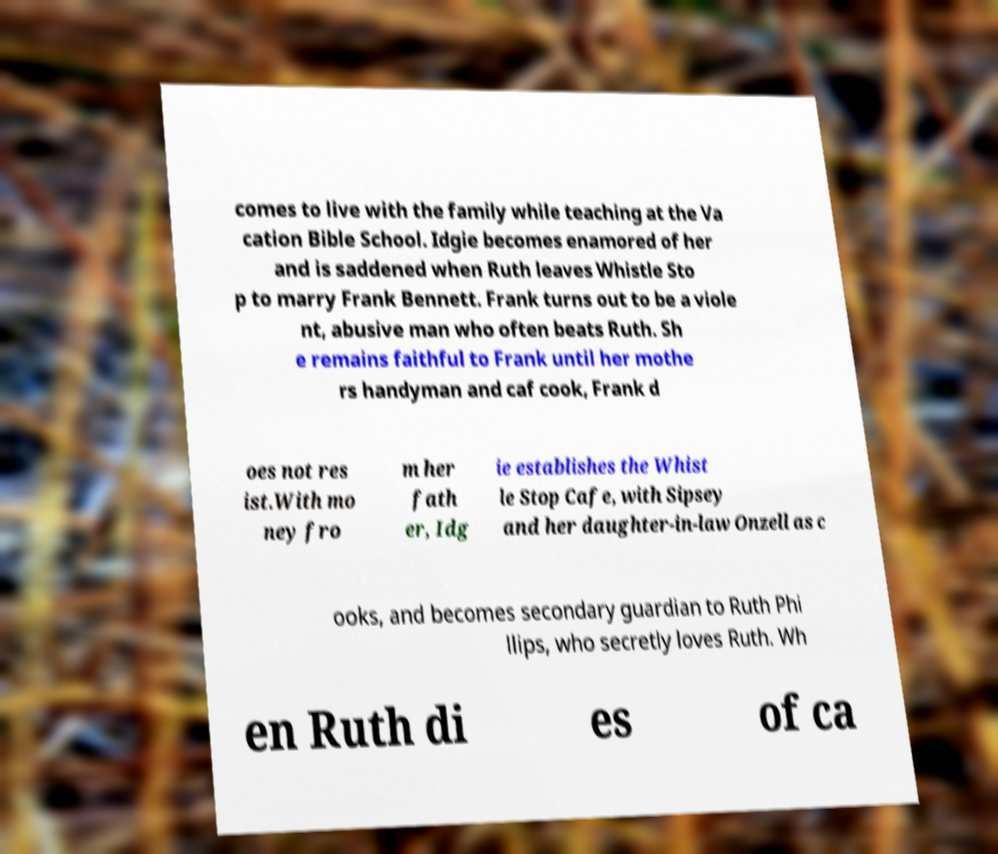There's text embedded in this image that I need extracted. Can you transcribe it verbatim? comes to live with the family while teaching at the Va cation Bible School. Idgie becomes enamored of her and is saddened when Ruth leaves Whistle Sto p to marry Frank Bennett. Frank turns out to be a viole nt, abusive man who often beats Ruth. Sh e remains faithful to Frank until her mothe rs handyman and caf cook, Frank d oes not res ist.With mo ney fro m her fath er, Idg ie establishes the Whist le Stop Cafe, with Sipsey and her daughter-in-law Onzell as c ooks, and becomes secondary guardian to Ruth Phi llips, who secretly loves Ruth. Wh en Ruth di es of ca 